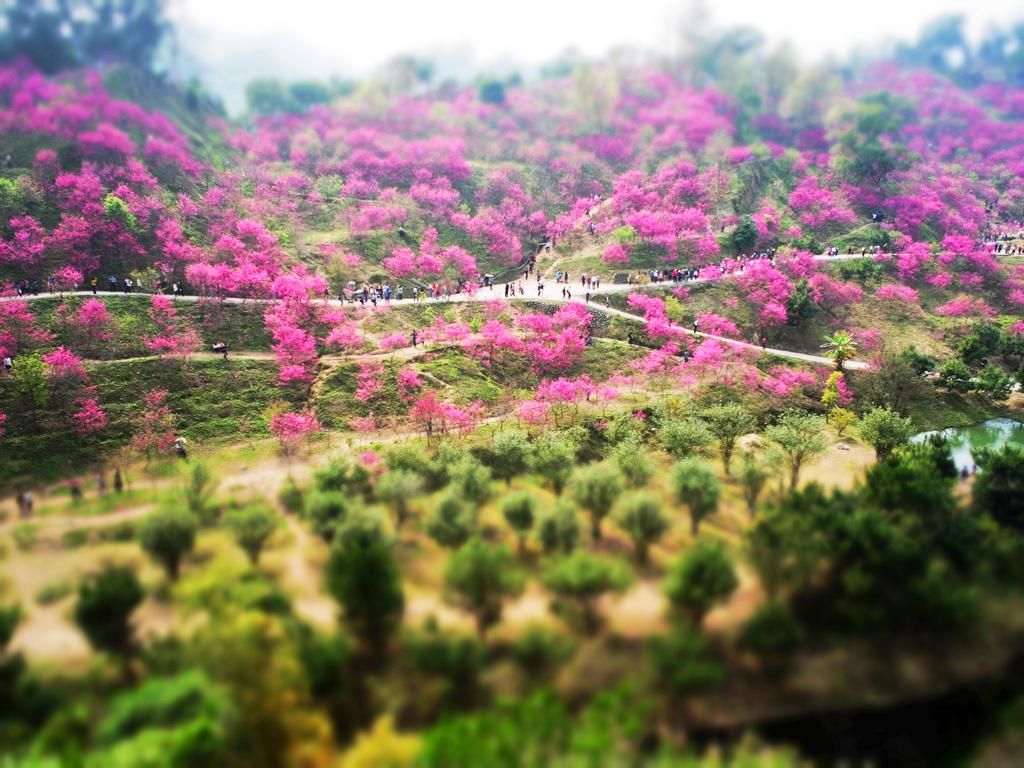What type of vegetation can be seen on the grassland in the image? There are trees on the grassland in the image. Where are the persons standing in the image? Some persons are standing on the road, while others are standing on the land. What is visible at the top of the image? The sky is visible at the top of the image. What is the name of the tooth in the image? There is no tooth present in the image. 